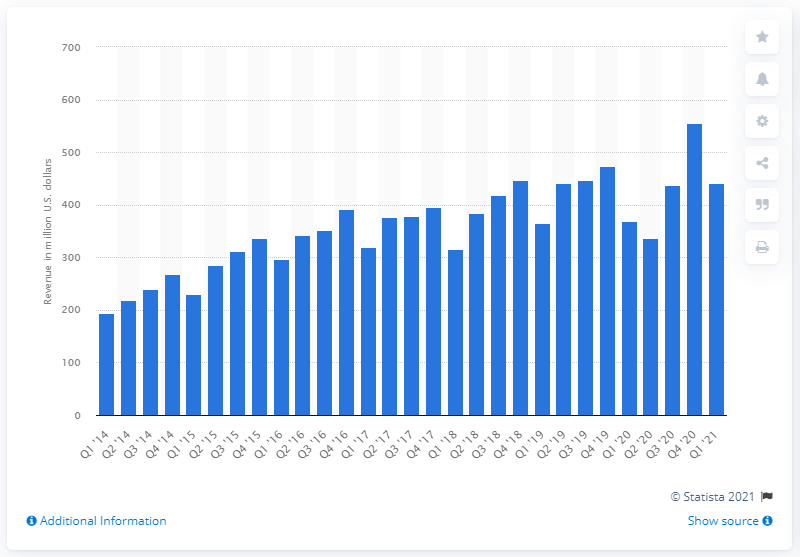Indicate a few pertinent items in this graphic. In the first quarter of 2021, Pandora generated approximately $442 million in revenue. In the fourth quarter of 2020, Pandora's total revenue was $555 million. 